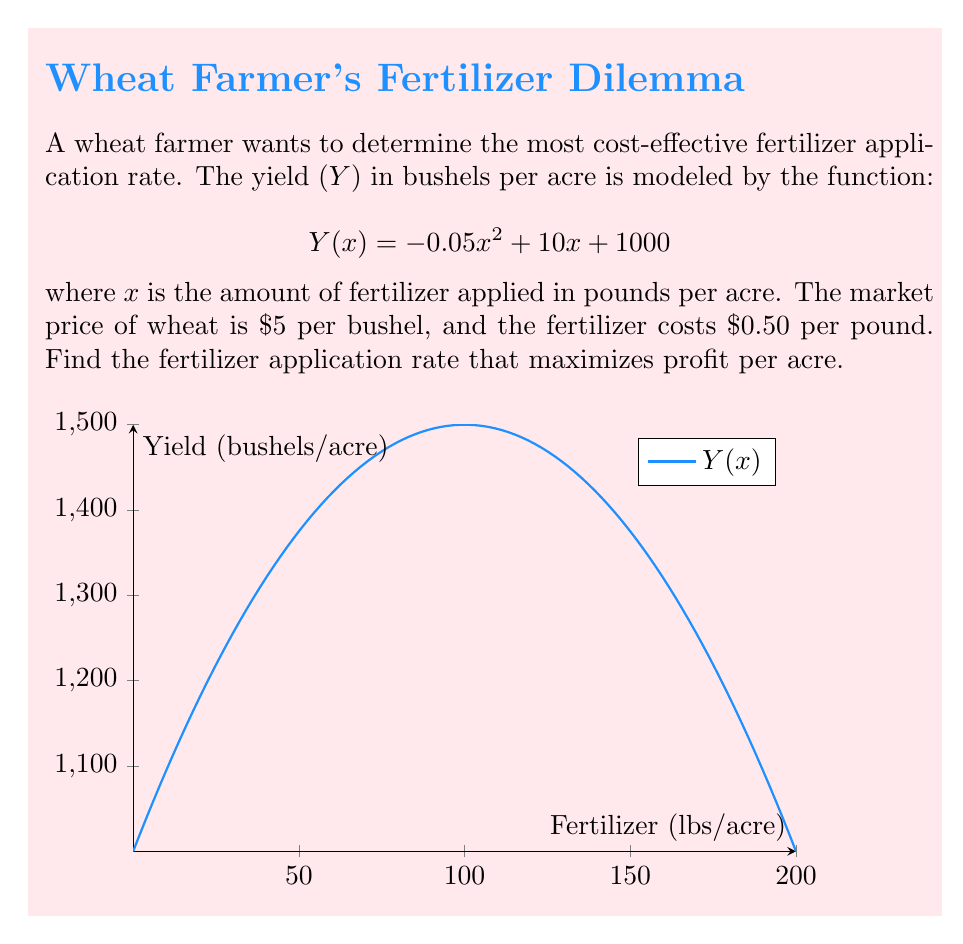Show me your answer to this math problem. Let's approach this step-by-step:

1) First, we need to set up a profit function. Profit is revenue minus cost:
   $$P(x) = 5Y(x) - 0.5x$$

2) Substitute the yield function:
   $$P(x) = 5(-0.05x^2 + 10x + 1000) - 0.5x$$

3) Simplify:
   $$P(x) = -0.25x^2 + 50x + 5000 - 0.5x$$
   $$P(x) = -0.25x^2 + 49.5x + 5000$$

4) To maximize profit, we find where the derivative of P(x) equals zero:
   $$P'(x) = -0.5x + 49.5$$

5) Set P'(x) = 0 and solve for x:
   $$-0.5x + 49.5 = 0$$
   $$-0.5x = -49.5$$
   $$x = 99$$

6) Verify this is a maximum by checking the second derivative:
   $$P''(x) = -0.5$$ (negative, confirming a maximum)

7) Therefore, the profit-maximizing fertilizer application rate is 99 pounds per acre.
Answer: 99 pounds per acre 